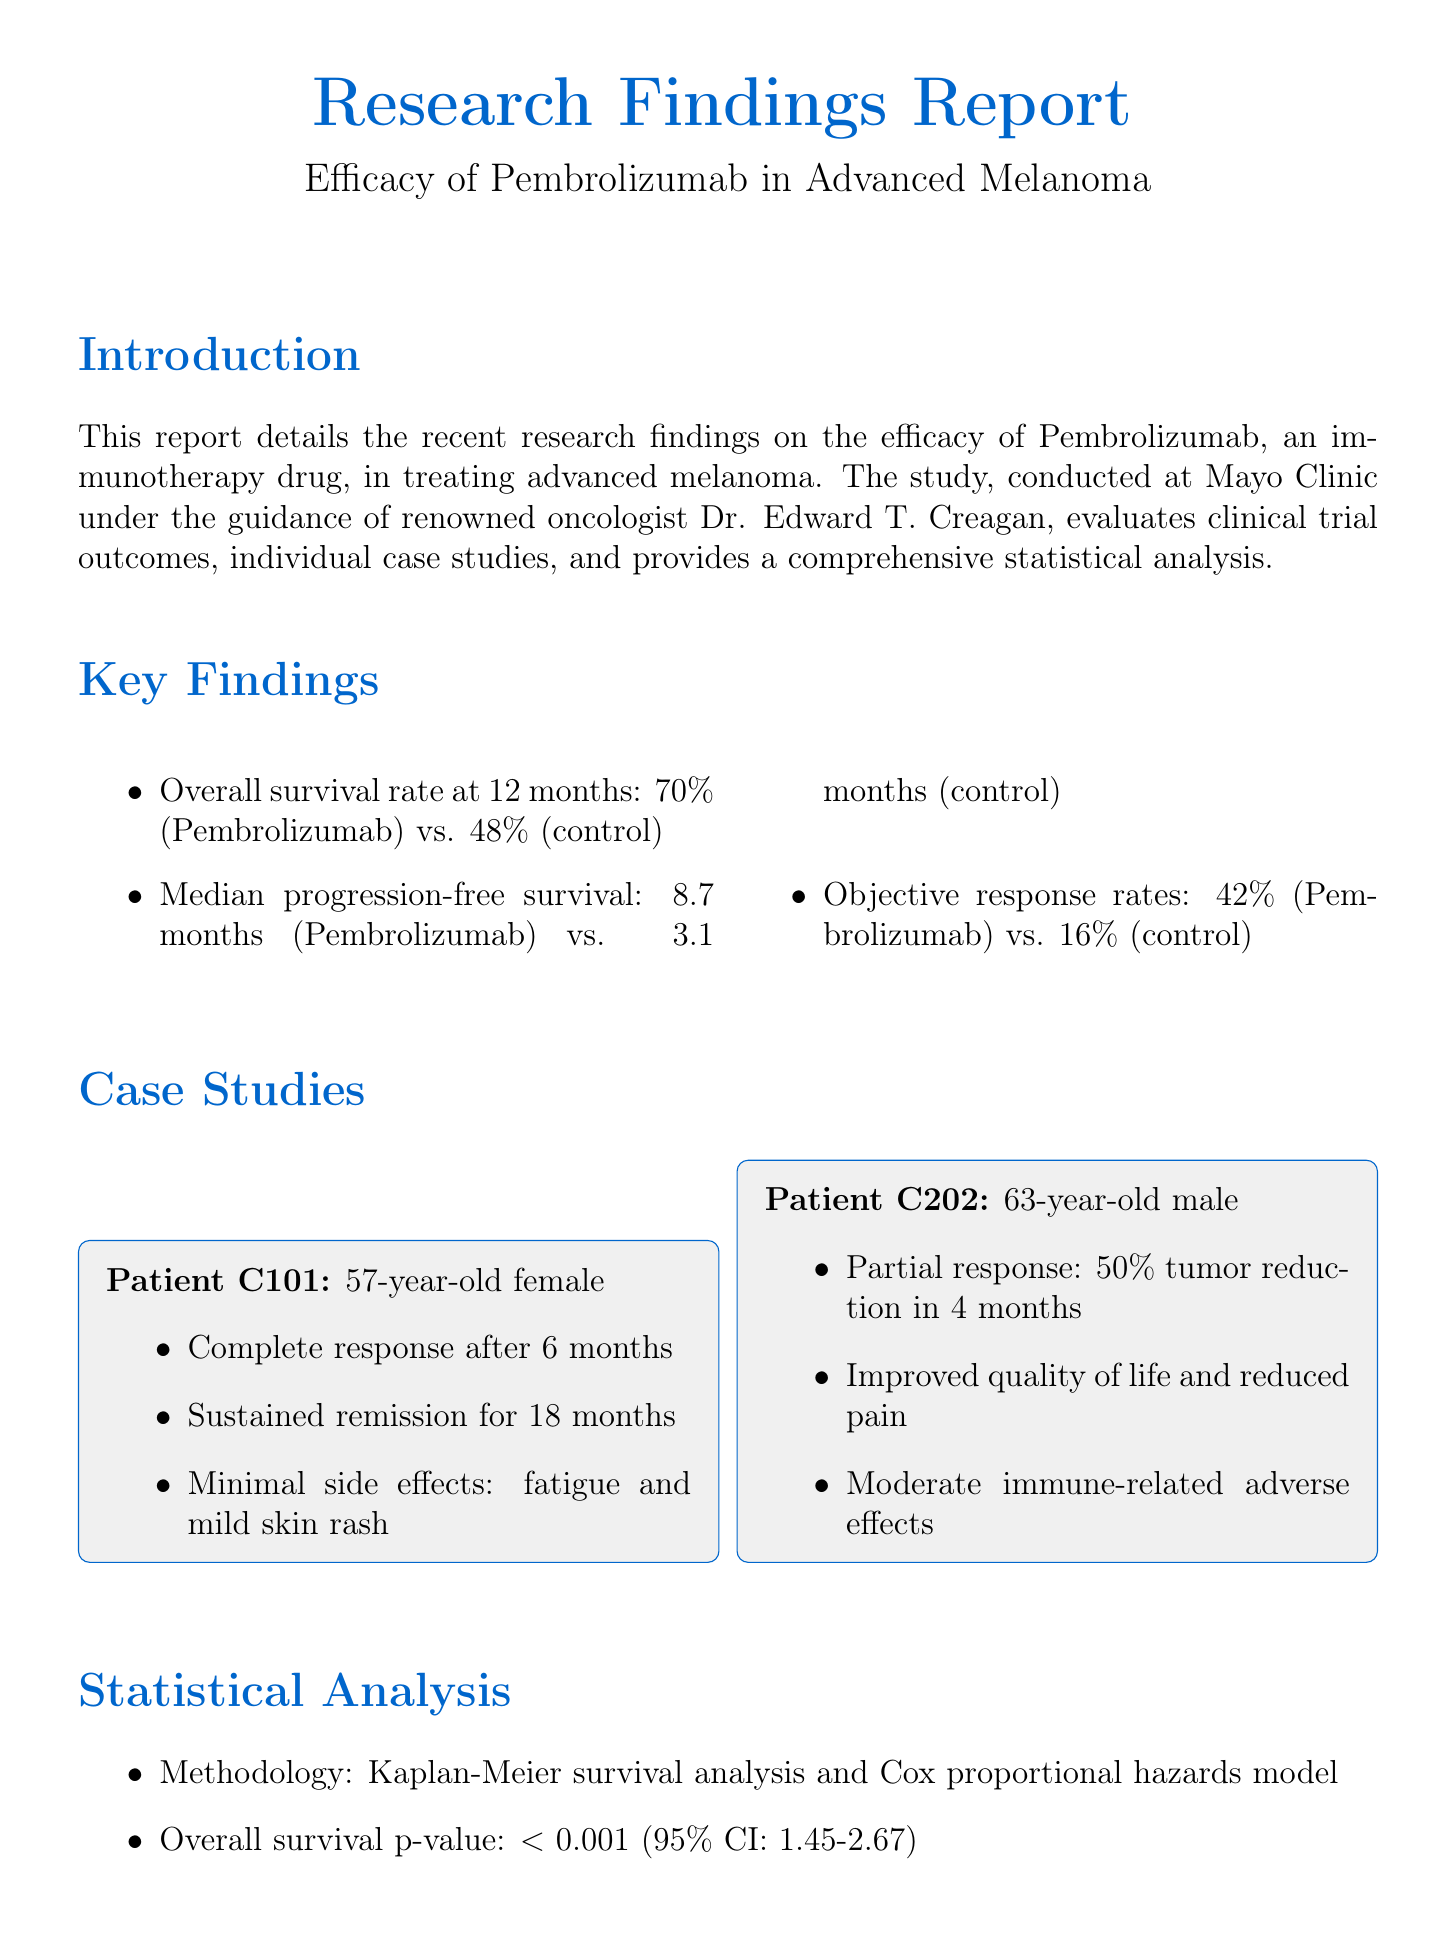What is the main drug evaluated in the report? The report focuses on the efficacy of Pembrolizumab as an immunotherapy drug.
Answer: Pembrolizumab What is the overall survival rate at 12 months for Pembrolizumab? The document states that the overall survival rate for Pembrolizumab is 70%.
Answer: 70% What was the median progression-free survival for the control group? According to the report, the median progression-free survival for the control group is 3.1 months.
Answer: 3.1 months What significant adverse effect was reported in Patient C202? Patient C202 experienced moderate immune-related adverse effects.
Answer: Moderate immune-related adverse effects What statistical method was used for survival analysis? The methodology used for survival analysis includes Kaplan-Meier survival analysis.
Answer: Kaplan-Meier survival analysis What was the p-value for overall survival? The overall survival p-value reported is less than 0.001.
Answer: Less than 0.001 How long did Patient C101 sustain remission after treatment? Patient C101 sustained remission for 18 months.
Answer: 18 months What is the objective response rate for Pembrolizumab? The document states that the objective response rate for Pembrolizumab is 42%.
Answer: 42% What is the purpose of this report? The report details the efficacy of Pembrolizumab in treating advanced melanoma based on research findings.
Answer: Efficacy of Pembrolizumab in treating advanced melanoma Who guided the study conducted at Mayo Clinic? The study was conducted under the guidance of Dr. Edward T. Creagan.
Answer: Dr. Edward T. Creagan 